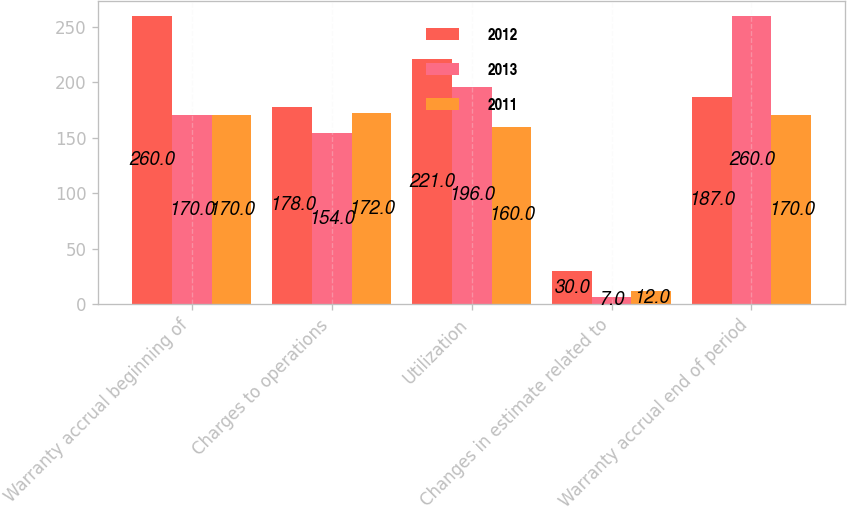<chart> <loc_0><loc_0><loc_500><loc_500><stacked_bar_chart><ecel><fcel>Warranty accrual beginning of<fcel>Charges to operations<fcel>Utilization<fcel>Changes in estimate related to<fcel>Warranty accrual end of period<nl><fcel>2012<fcel>260<fcel>178<fcel>221<fcel>30<fcel>187<nl><fcel>2013<fcel>170<fcel>154<fcel>196<fcel>7<fcel>260<nl><fcel>2011<fcel>170<fcel>172<fcel>160<fcel>12<fcel>170<nl></chart> 